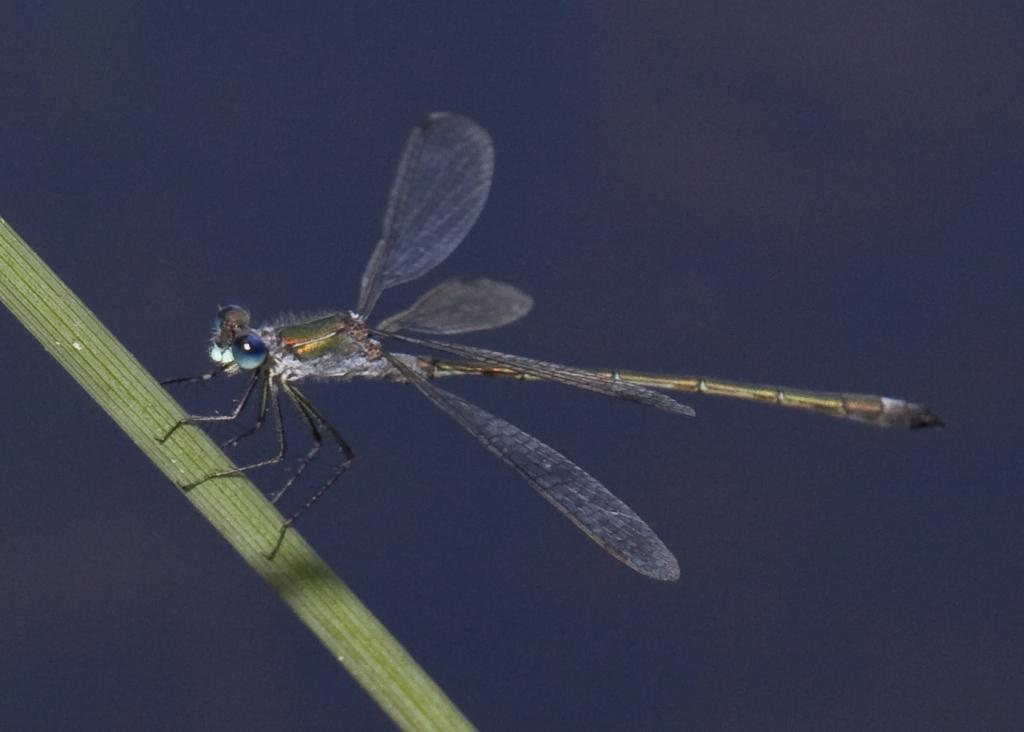What is on the green leaf in the image? There is an insect on a green color leaf. What features does the insect have? The insect has wings and legs. What color is the background of the image? The background color is violet. What type of trouble is the insect causing with the basket in the image? There is no basket present in the image, so the insect is not causing any trouble with a basket. 